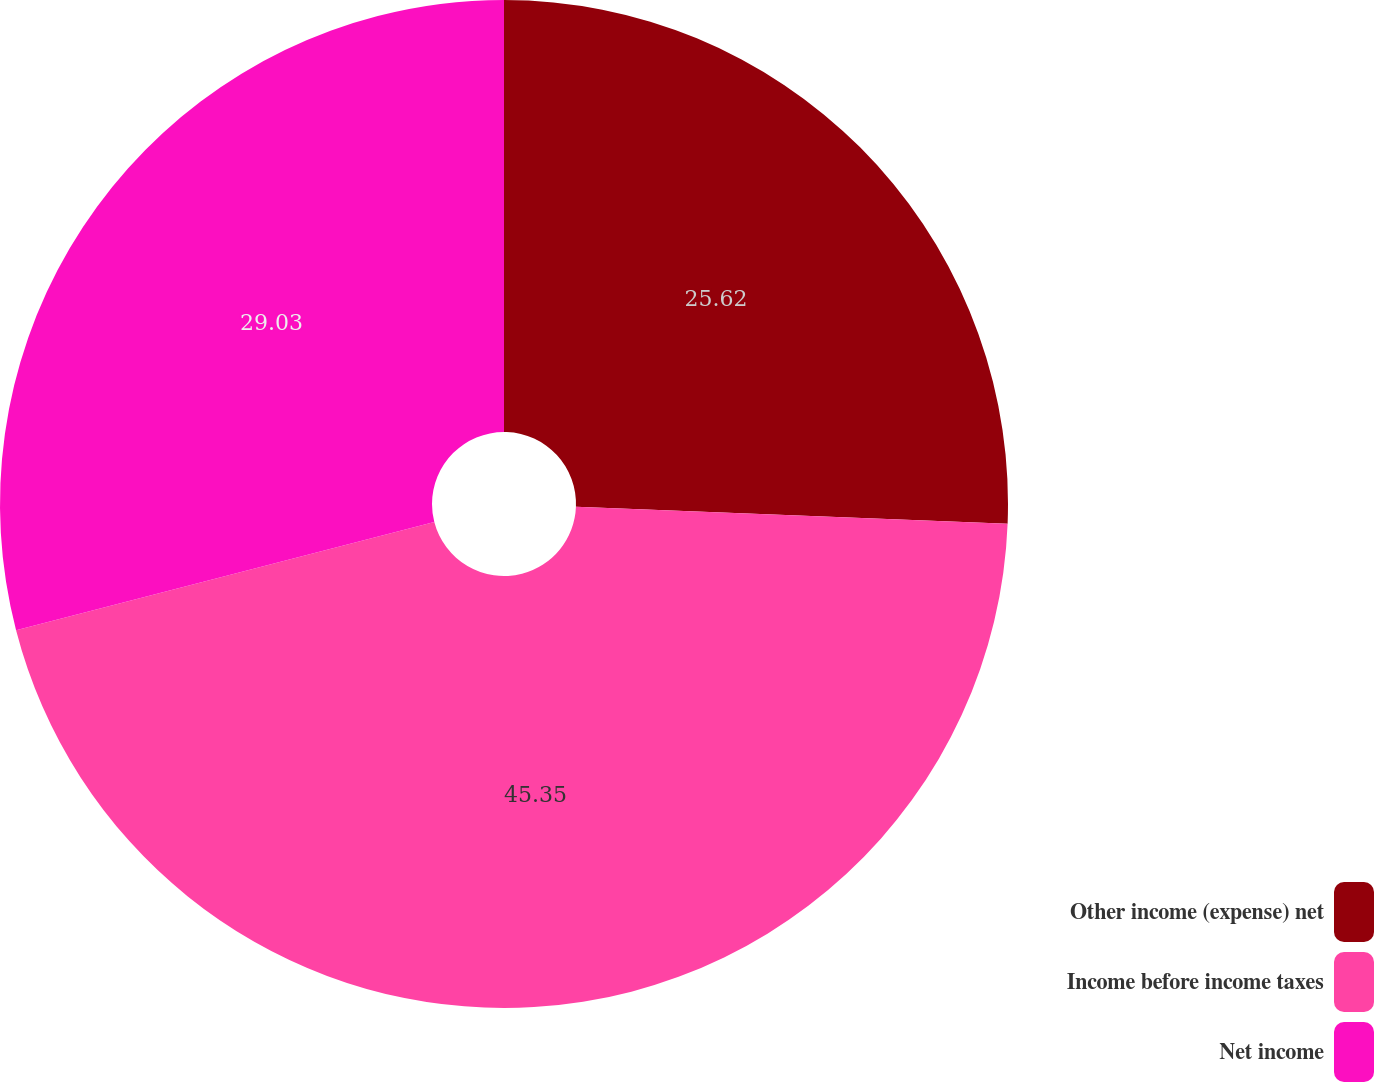Convert chart. <chart><loc_0><loc_0><loc_500><loc_500><pie_chart><fcel>Other income (expense) net<fcel>Income before income taxes<fcel>Net income<nl><fcel>25.62%<fcel>45.35%<fcel>29.03%<nl></chart> 